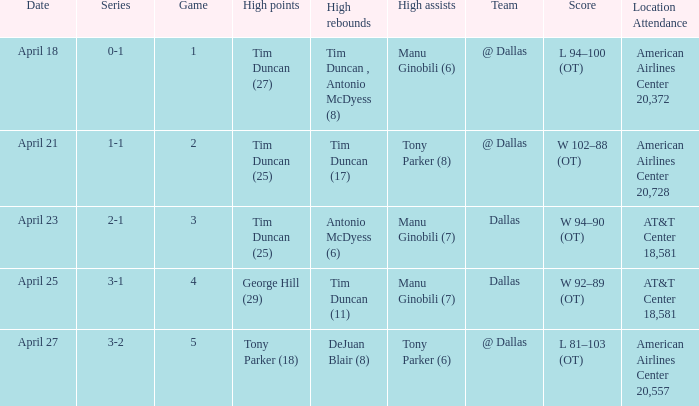When george hill (29) has the highest amount of points what is the date? April 25. 